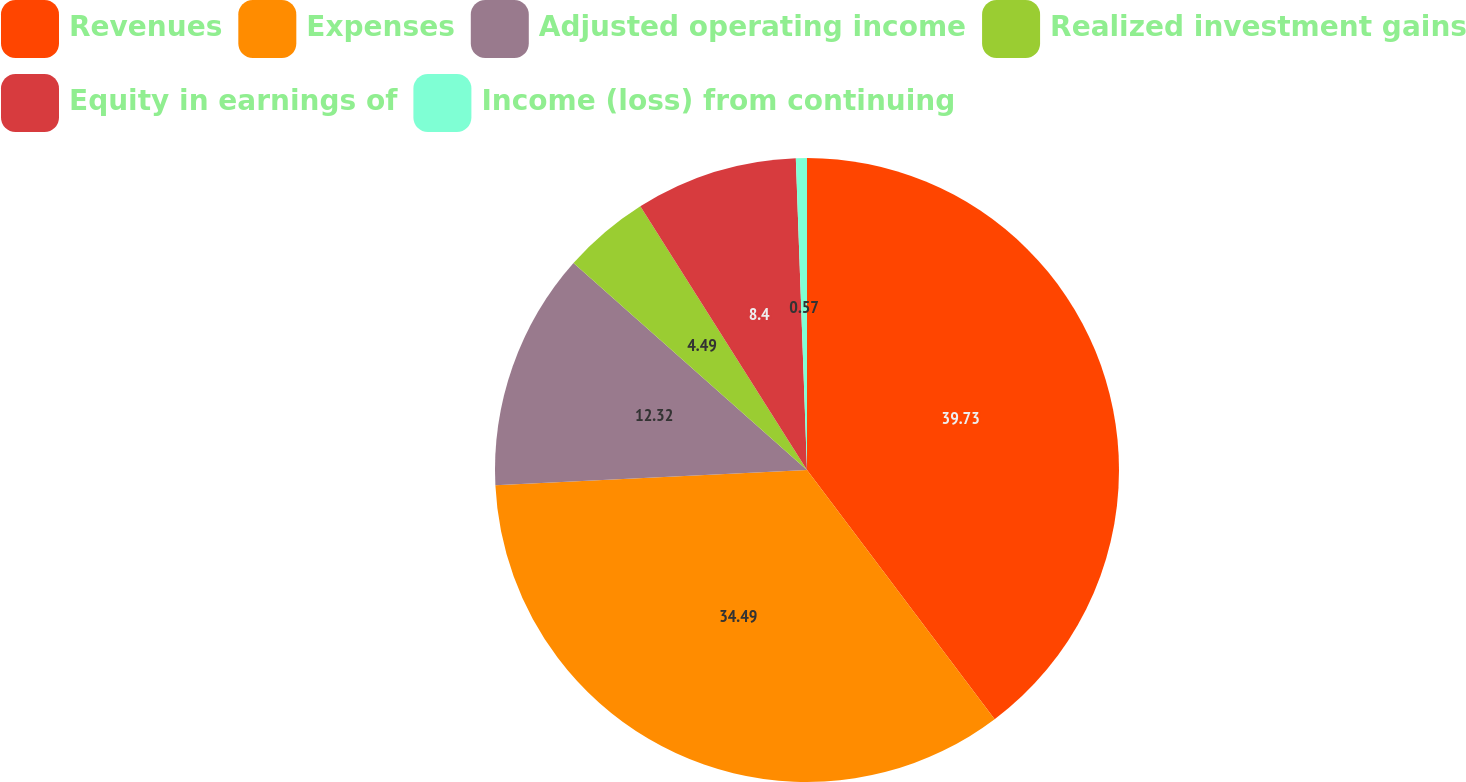<chart> <loc_0><loc_0><loc_500><loc_500><pie_chart><fcel>Revenues<fcel>Expenses<fcel>Adjusted operating income<fcel>Realized investment gains<fcel>Equity in earnings of<fcel>Income (loss) from continuing<nl><fcel>39.73%<fcel>34.49%<fcel>12.32%<fcel>4.49%<fcel>8.4%<fcel>0.57%<nl></chart> 